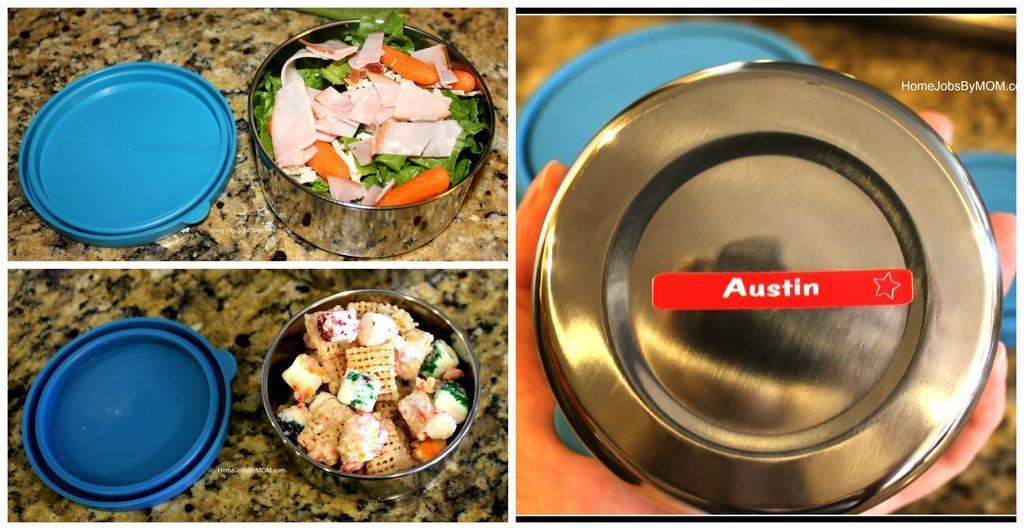Can you describe this image briefly? In this image we can see three collage pictures, in those pictures, there are some food items in the boxes, which are on the granite surface, there are caps, there is a box in the hand of a person, also we can see the text on the image. 